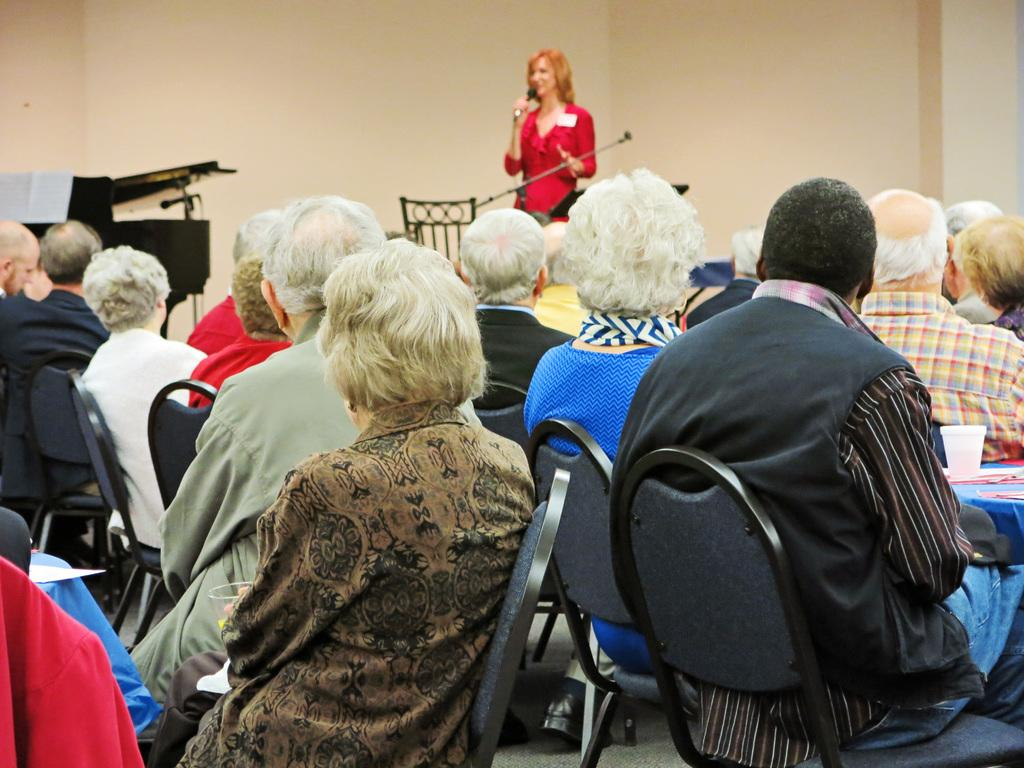What are the people in the image doing? A group of people are sitting on chairs in the image. What object can be seen near the people? A glass is visible in the image. What musical instrument is present in the image? There is a piano in the image. What is used to hold the mic for the woman? A stand is present in the image. What is the woman doing in the image? The woman is holding a mic with her hand and standing in the image. What can be seen in the background of the image? There is a wall in the background of the image. What type of notebook is the woman using to write down her thoughts in the image? There is no notebook present in the image; the woman is holding a mic and standing near a piano. What activity is the group of people participating in, as seen in the image? The image does not show a specific activity, but the presence of a piano, a woman holding a mic, and a group of people sitting on chairs suggests a musical performance or rehearsal. 